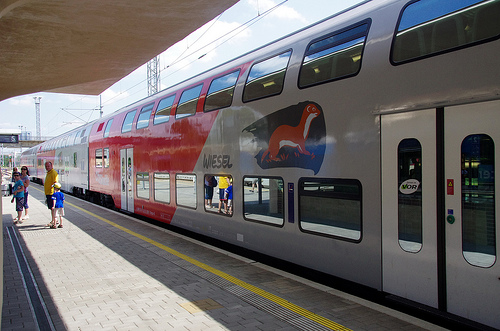What activities can you see happening around the train in this image? In the image, a family appears to be waiting for the train, and an individual is boarding the train. A child wearing a cap stands by, suggesting preparations for a journey. Over what landscapes does the train typically travel? This train likely traverses diverse scenarios, including urban areas marked by structures and bustling activity, as well as more quiet, rural landscapes seen from the window views during transit. 